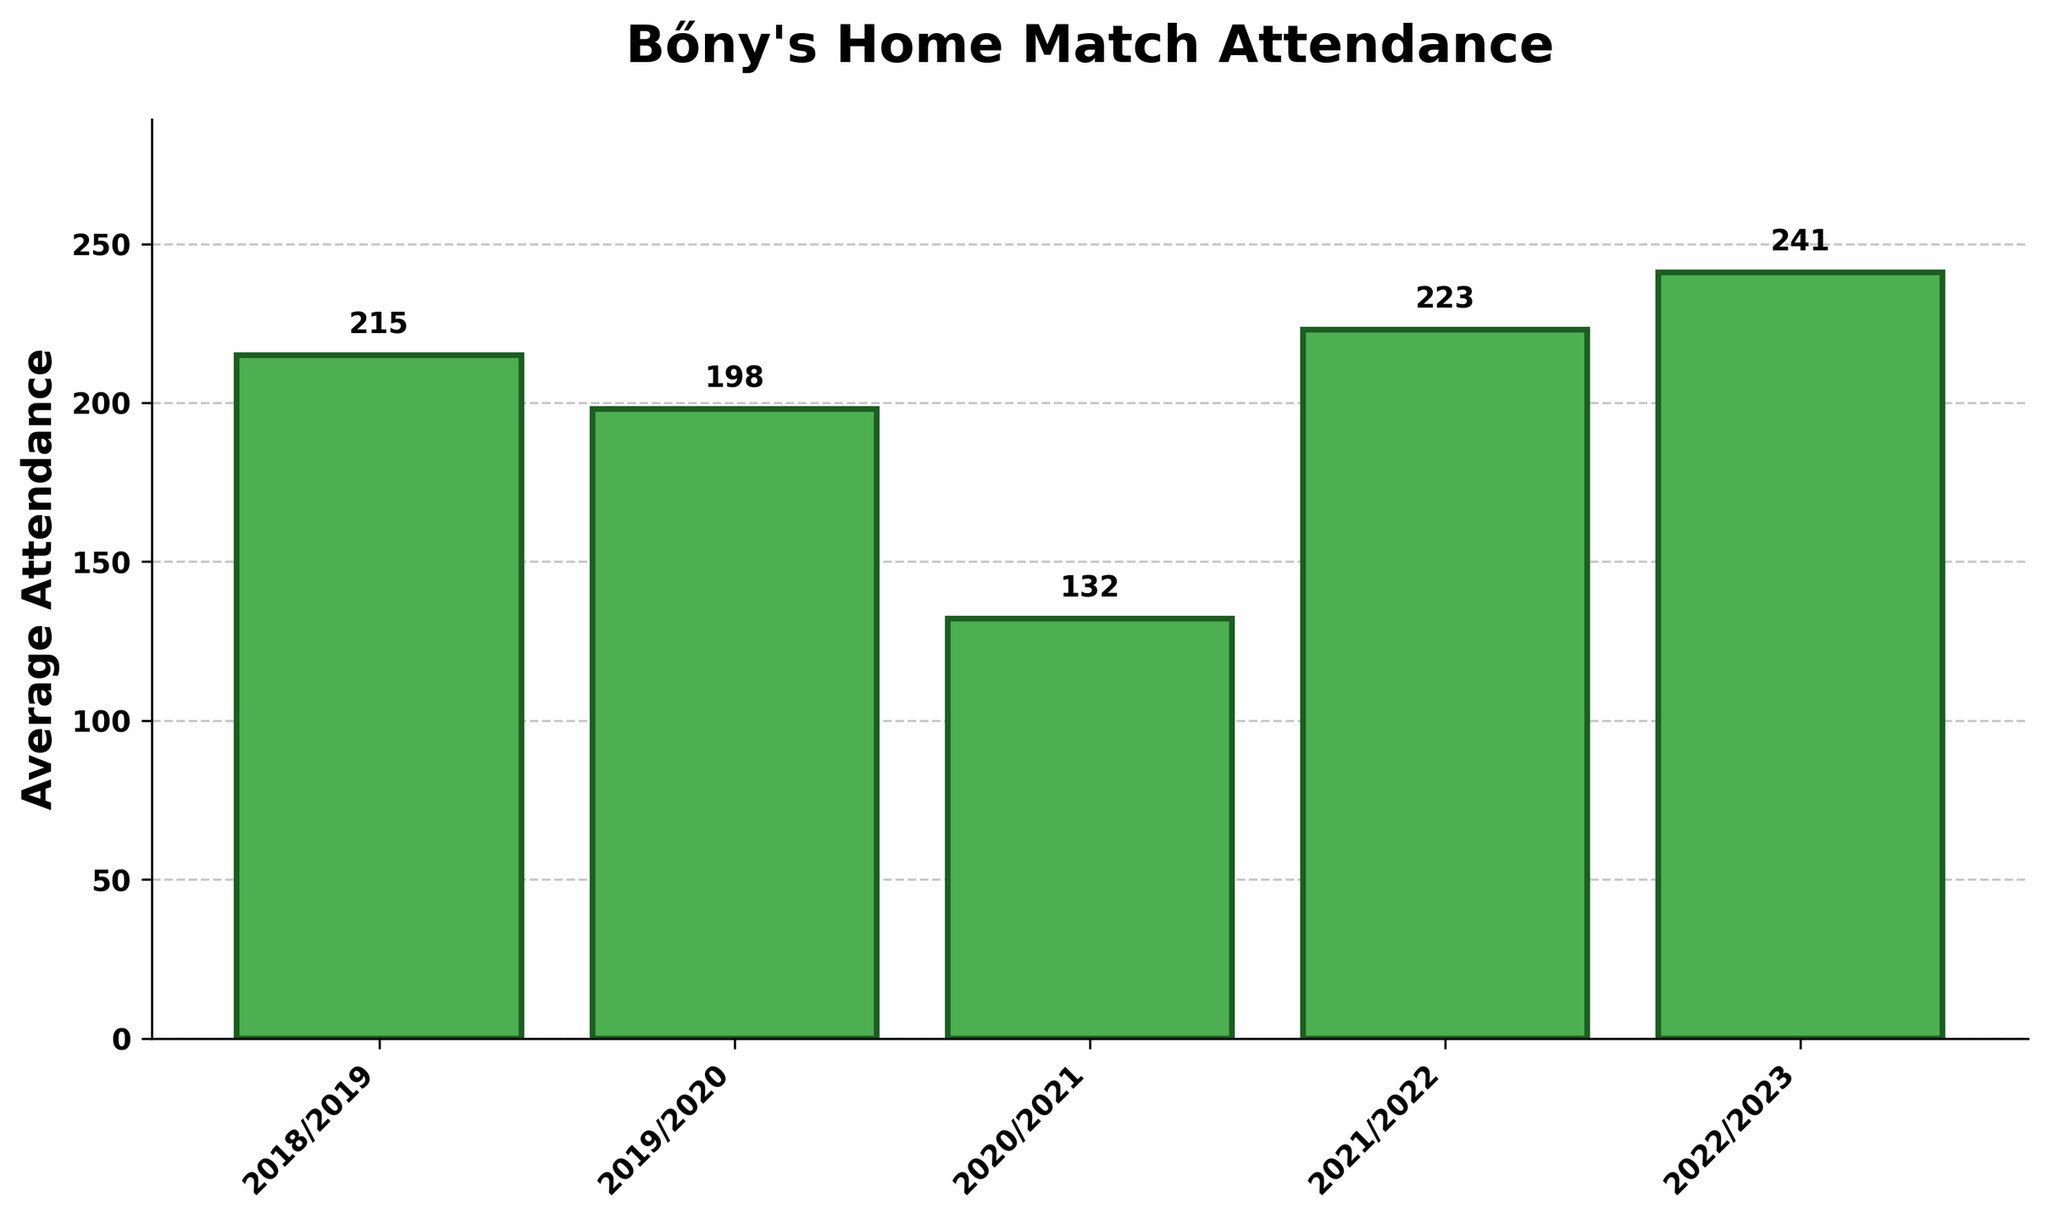Which season had the highest average attendance? To find the season with the highest average attendance, identify the tallest bar in the bar chart. The tallest bar corresponds to the 2022/2023 season, which has an average attendance of 241.
Answer: 2022/2023 What is the difference in average attendance between the 2022/2023 and 2020/2021 seasons? Find the average attendances for both seasons: 241 for 2022/2023 and 132 for 2020/2021. Then, subtract the smaller value from the larger value: 241 - 132 = 109.
Answer: 109 In which season did Bőny experience the lowest average attendance for home matches? Identify the shortest bar. The shortest bar is for the 2020/2021 season, which has an average attendance of 132.
Answer: 2020/2021 Did the average attendance increase or decrease from the 2018/2019 season to the 2019/2020 season? Compare the heights of the bars for 2018/2019 (215) and 2019/2020 (198). The bar for 2019/2020 is shorter, indicating a decrease.
Answer: Decrease What was the total average attendance over all five seasons? Sum the individual average attendances: 215 (2018/2019) + 198 (2019/2020) + 132 (2020/2021) + 223 (2021/2022) + 241 (2022/2023). The sum is 1009.
Answer: 1009 Which season showed the greatest increase in average attendance compared to the previous season? Calculate the increase for each season compared to the previous one: 
2019/2020 vs. 2018/2019: 198 - 215 = -17 
2020/2021 vs. 2019/2020: 132 - 198 = -66 
2021/2022 vs. 2020/2021: 223 - 132 = 91 
2022/2023 vs. 2021/2022: 241 - 223 = 18 
The greatest increase is 91, from 2020/2021 to 2021/2022.
Answer: 2021/2022 How does the average attendance in the 2021/2022 season compare to the average attendance in the 2018/2019 season? Compare the values for 2021/2022 (223) and 2018/2019 (215). The average attendance in 2021/2022 is higher by 223 - 215 = 8.
Answer: Higher by 8 How many seasons saw an average attendance greater than 200? Count the bars whose heights correspond to values greater than 200: 2018/2019 (215), 2021/2022 (223), and 2022/2023 (241). There are three such seasons.
Answer: 3 